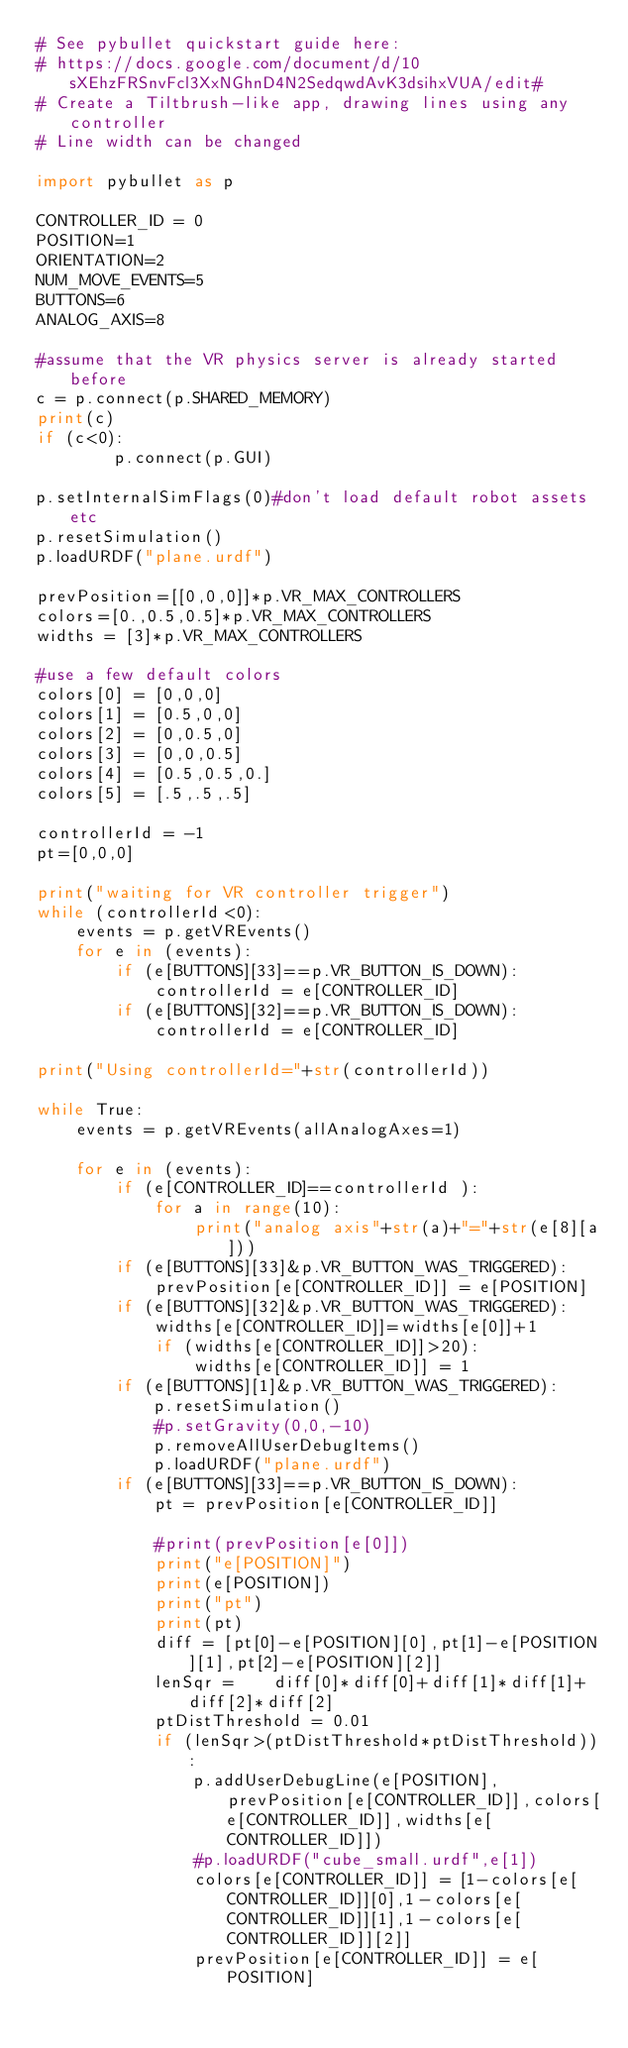<code> <loc_0><loc_0><loc_500><loc_500><_Python_># See pybullet quickstart guide here:
# https://docs.google.com/document/d/10sXEhzFRSnvFcl3XxNGhnD4N2SedqwdAvK3dsihxVUA/edit#
# Create a Tiltbrush-like app, drawing lines using any controller
# Line width can be changed

import pybullet as p

CONTROLLER_ID = 0
POSITION=1
ORIENTATION=2
NUM_MOVE_EVENTS=5
BUTTONS=6
ANALOG_AXIS=8

#assume that the VR physics server is already started before
c = p.connect(p.SHARED_MEMORY)
print(c)
if (c<0):
		p.connect(p.GUI)

p.setInternalSimFlags(0)#don't load default robot assets etc
p.resetSimulation()
p.loadURDF("plane.urdf")

prevPosition=[[0,0,0]]*p.VR_MAX_CONTROLLERS
colors=[0.,0.5,0.5]*p.VR_MAX_CONTROLLERS
widths = [3]*p.VR_MAX_CONTROLLERS

#use a few default colors
colors[0] = [0,0,0]
colors[1] = [0.5,0,0]
colors[2] = [0,0.5,0]
colors[3] = [0,0,0.5]
colors[4] = [0.5,0.5,0.]
colors[5] = [.5,.5,.5]

controllerId = -1
pt=[0,0,0]

print("waiting for VR controller trigger")
while (controllerId<0):
	events = p.getVREvents()
	for e in (events):
		if (e[BUTTONS][33]==p.VR_BUTTON_IS_DOWN):
			controllerId = e[CONTROLLER_ID]
		if (e[BUTTONS][32]==p.VR_BUTTON_IS_DOWN):
			controllerId = e[CONTROLLER_ID]

print("Using controllerId="+str(controllerId))

while True:
	events = p.getVREvents(allAnalogAxes=1)

	for e in (events):
		if (e[CONTROLLER_ID]==controllerId ):
			for a in range(10):
				print("analog axis"+str(a)+"="+str(e[8][a]))
		if (e[BUTTONS][33]&p.VR_BUTTON_WAS_TRIGGERED):
			prevPosition[e[CONTROLLER_ID]] = e[POSITION]
		if (e[BUTTONS][32]&p.VR_BUTTON_WAS_TRIGGERED):
			widths[e[CONTROLLER_ID]]=widths[e[0]]+1
			if (widths[e[CONTROLLER_ID]]>20):
				widths[e[CONTROLLER_ID]] = 1
		if (e[BUTTONS][1]&p.VR_BUTTON_WAS_TRIGGERED):
			p.resetSimulation()
			#p.setGravity(0,0,-10)
			p.removeAllUserDebugItems()
			p.loadURDF("plane.urdf")
		if (e[BUTTONS][33]==p.VR_BUTTON_IS_DOWN):
			pt = prevPosition[e[CONTROLLER_ID]]
			
			#print(prevPosition[e[0]])
			print("e[POSITION]")
			print(e[POSITION])
			print("pt")
			print(pt)
			diff = [pt[0]-e[POSITION][0],pt[1]-e[POSITION][1],pt[2]-e[POSITION][2]]
			lenSqr =	diff[0]*diff[0]+diff[1]*diff[1]+diff[2]*diff[2]
			ptDistThreshold = 0.01
			if (lenSqr>(ptDistThreshold*ptDistThreshold)):
				p.addUserDebugLine(e[POSITION],prevPosition[e[CONTROLLER_ID]],colors[e[CONTROLLER_ID]],widths[e[CONTROLLER_ID]])
				#p.loadURDF("cube_small.urdf",e[1])
				colors[e[CONTROLLER_ID]] = [1-colors[e[CONTROLLER_ID]][0],1-colors[e[CONTROLLER_ID]][1],1-colors[e[CONTROLLER_ID]][2]]
				prevPosition[e[CONTROLLER_ID]] = e[POSITION]			</code> 